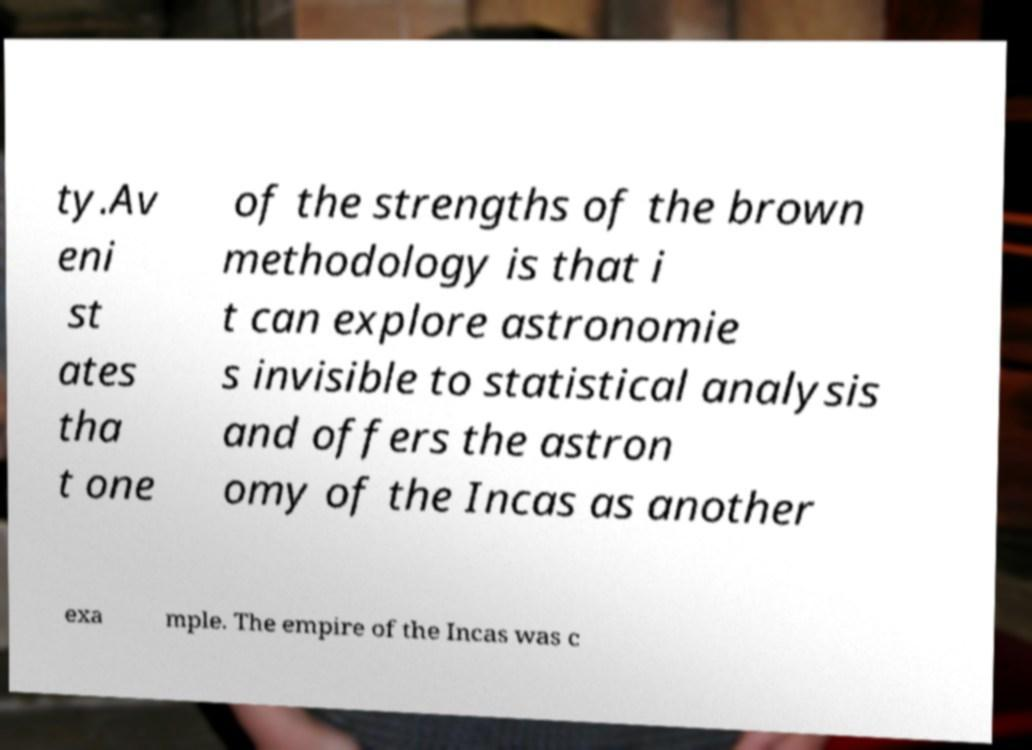Please identify and transcribe the text found in this image. ty.Av eni st ates tha t one of the strengths of the brown methodology is that i t can explore astronomie s invisible to statistical analysis and offers the astron omy of the Incas as another exa mple. The empire of the Incas was c 